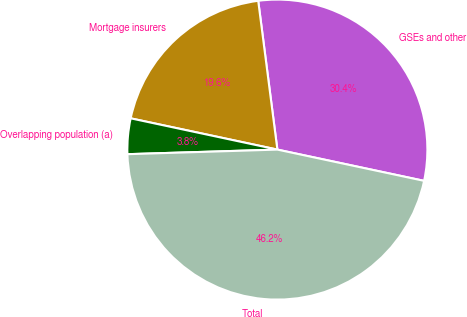Convert chart to OTSL. <chart><loc_0><loc_0><loc_500><loc_500><pie_chart><fcel>GSEs and other<fcel>Mortgage insurers<fcel>Overlapping population (a)<fcel>Total<nl><fcel>30.38%<fcel>19.62%<fcel>3.83%<fcel>46.17%<nl></chart> 